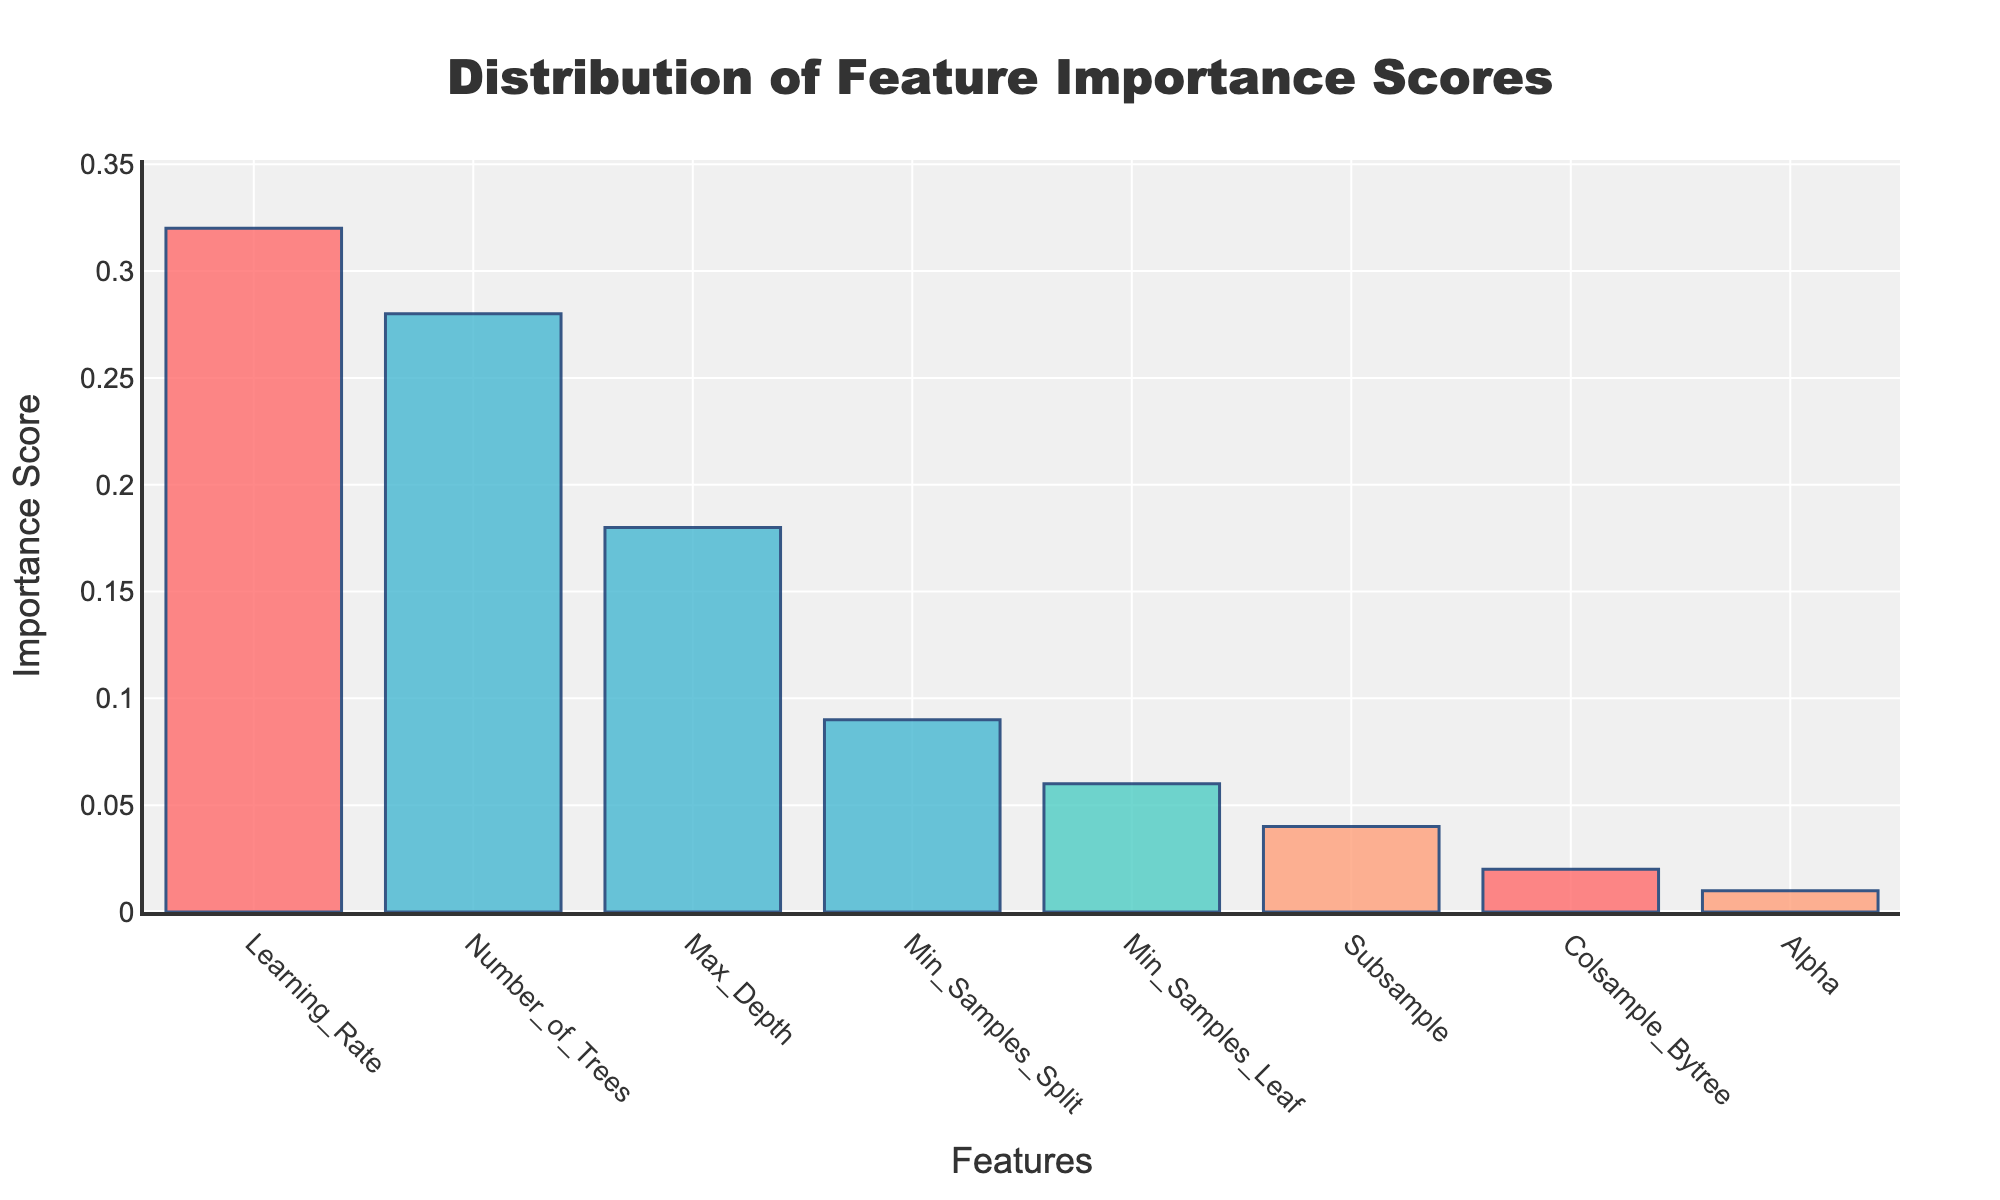What is the title of the histogram? The title is typically located at the top of the chart and is meant to give a quick insight into what the chart is about.
Answer: Distribution of Feature Importance Scores Which feature has the highest importance score? By looking at the bars in the histogram, you can quickly identify the tallest bar. The feature that this bar represents will have the highest importance score.
Answer: Learning_Rate What are the importance scores of Number_of_Trees and Min_Samples_Split? Refer to the height of the bars labeled Number_of_Trees and Min_Samples_Split to get their importance scores.
Answer: 0.28 and 0.09 Which feature has the lowest importance score and what is it? The lowest bar represents the feature with the lowest importance score. Look at the corresponding x-axis label to identify the feature.
Answer: Alpha, 0.01 What is the combined importance score of Learning_Rate and Max_Depth? Add the importance scores of Learning_Rate and Max_Depth: 0.32 + 0.18 = 0.5
Answer: 0.5 How much greater is the importance score of Learning_Rate than Number_of_Trees? Subtract the importance score of Number_of_Trees from Learning_Rate: 0.32 - 0.28 = 0.04
Answer: 0.04 What is the average importance score of Subsample, Colsample_Bytree, and Alpha? Add the scores and divide by the number of features: (0.04 + 0.02 + 0.01) / 3 = 0.0233
Answer: 0.0233 Which three features have the highest importance scores? Identify the three tallest bars and note their x-axis labels.
Answer: Learning_Rate, Number_of_Trees, Max_Depth How many features have an importance score greater than 0.1? Count the number of bars that extend above the 0.1 mark on the y-axis.
Answer: 3 What feature has an importance score of 0.06? Find the bar corresponding to the height of 0.06 and read its x-axis label.
Answer: Min_Samples_Leaf 